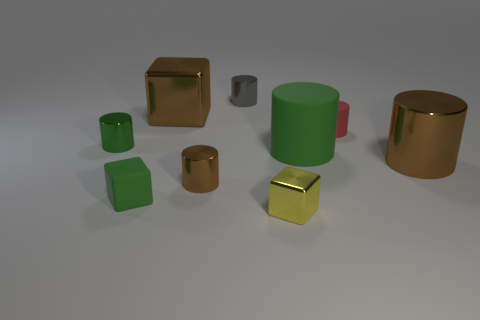Subtract all brown cylinders. How many cylinders are left? 4 Subtract all big cylinders. How many cylinders are left? 4 Subtract all yellow cylinders. Subtract all gray blocks. How many cylinders are left? 6 Add 1 small blue things. How many objects exist? 10 Subtract all cylinders. How many objects are left? 3 Add 7 green objects. How many green objects are left? 10 Add 1 brown metallic things. How many brown metallic things exist? 4 Subtract 0 cyan cylinders. How many objects are left? 9 Subtract all brown blocks. Subtract all large green things. How many objects are left? 7 